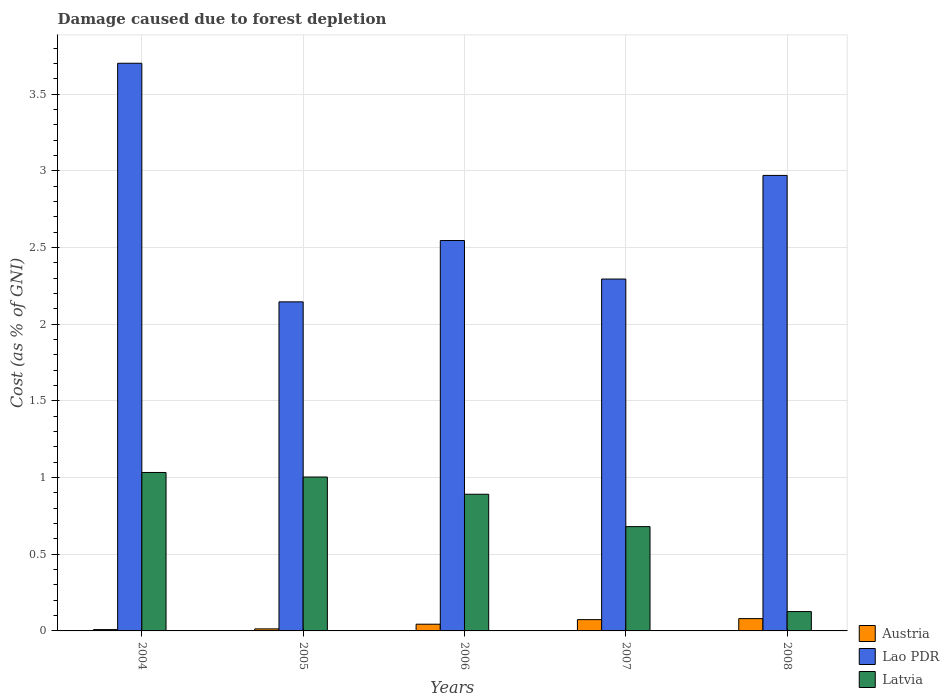Are the number of bars per tick equal to the number of legend labels?
Your answer should be very brief. Yes. How many bars are there on the 2nd tick from the left?
Provide a succinct answer. 3. In how many cases, is the number of bars for a given year not equal to the number of legend labels?
Your response must be concise. 0. What is the cost of damage caused due to forest depletion in Lao PDR in 2005?
Provide a succinct answer. 2.15. Across all years, what is the maximum cost of damage caused due to forest depletion in Lao PDR?
Make the answer very short. 3.7. Across all years, what is the minimum cost of damage caused due to forest depletion in Austria?
Make the answer very short. 0.01. In which year was the cost of damage caused due to forest depletion in Lao PDR maximum?
Offer a very short reply. 2004. In which year was the cost of damage caused due to forest depletion in Austria minimum?
Provide a succinct answer. 2004. What is the total cost of damage caused due to forest depletion in Austria in the graph?
Your response must be concise. 0.22. What is the difference between the cost of damage caused due to forest depletion in Lao PDR in 2005 and that in 2006?
Offer a very short reply. -0.4. What is the difference between the cost of damage caused due to forest depletion in Latvia in 2005 and the cost of damage caused due to forest depletion in Austria in 2004?
Ensure brevity in your answer.  1. What is the average cost of damage caused due to forest depletion in Lao PDR per year?
Provide a succinct answer. 2.73. In the year 2005, what is the difference between the cost of damage caused due to forest depletion in Lao PDR and cost of damage caused due to forest depletion in Latvia?
Your answer should be very brief. 1.14. In how many years, is the cost of damage caused due to forest depletion in Lao PDR greater than 3.7 %?
Provide a succinct answer. 1. What is the ratio of the cost of damage caused due to forest depletion in Lao PDR in 2004 to that in 2008?
Offer a very short reply. 1.25. What is the difference between the highest and the second highest cost of damage caused due to forest depletion in Austria?
Ensure brevity in your answer.  0.01. What is the difference between the highest and the lowest cost of damage caused due to forest depletion in Austria?
Your answer should be very brief. 0.07. In how many years, is the cost of damage caused due to forest depletion in Lao PDR greater than the average cost of damage caused due to forest depletion in Lao PDR taken over all years?
Provide a succinct answer. 2. Is the sum of the cost of damage caused due to forest depletion in Austria in 2005 and 2007 greater than the maximum cost of damage caused due to forest depletion in Latvia across all years?
Provide a short and direct response. No. What does the 3rd bar from the left in 2004 represents?
Ensure brevity in your answer.  Latvia. What does the 3rd bar from the right in 2006 represents?
Make the answer very short. Austria. How many bars are there?
Give a very brief answer. 15. Are all the bars in the graph horizontal?
Offer a very short reply. No. Are the values on the major ticks of Y-axis written in scientific E-notation?
Keep it short and to the point. No. Does the graph contain any zero values?
Ensure brevity in your answer.  No. How many legend labels are there?
Ensure brevity in your answer.  3. How are the legend labels stacked?
Offer a terse response. Vertical. What is the title of the graph?
Keep it short and to the point. Damage caused due to forest depletion. Does "Korea (Democratic)" appear as one of the legend labels in the graph?
Provide a succinct answer. No. What is the label or title of the X-axis?
Offer a terse response. Years. What is the label or title of the Y-axis?
Provide a succinct answer. Cost (as % of GNI). What is the Cost (as % of GNI) of Austria in 2004?
Give a very brief answer. 0.01. What is the Cost (as % of GNI) of Lao PDR in 2004?
Offer a terse response. 3.7. What is the Cost (as % of GNI) in Latvia in 2004?
Ensure brevity in your answer.  1.03. What is the Cost (as % of GNI) of Austria in 2005?
Ensure brevity in your answer.  0.01. What is the Cost (as % of GNI) of Lao PDR in 2005?
Provide a succinct answer. 2.15. What is the Cost (as % of GNI) of Latvia in 2005?
Offer a terse response. 1. What is the Cost (as % of GNI) in Austria in 2006?
Give a very brief answer. 0.04. What is the Cost (as % of GNI) in Lao PDR in 2006?
Make the answer very short. 2.55. What is the Cost (as % of GNI) of Latvia in 2006?
Give a very brief answer. 0.89. What is the Cost (as % of GNI) of Austria in 2007?
Offer a terse response. 0.07. What is the Cost (as % of GNI) in Lao PDR in 2007?
Provide a succinct answer. 2.29. What is the Cost (as % of GNI) of Latvia in 2007?
Provide a short and direct response. 0.68. What is the Cost (as % of GNI) of Austria in 2008?
Make the answer very short. 0.08. What is the Cost (as % of GNI) in Lao PDR in 2008?
Provide a short and direct response. 2.97. What is the Cost (as % of GNI) of Latvia in 2008?
Provide a succinct answer. 0.13. Across all years, what is the maximum Cost (as % of GNI) of Austria?
Your answer should be very brief. 0.08. Across all years, what is the maximum Cost (as % of GNI) of Lao PDR?
Offer a very short reply. 3.7. Across all years, what is the maximum Cost (as % of GNI) in Latvia?
Your response must be concise. 1.03. Across all years, what is the minimum Cost (as % of GNI) in Austria?
Keep it short and to the point. 0.01. Across all years, what is the minimum Cost (as % of GNI) in Lao PDR?
Make the answer very short. 2.15. Across all years, what is the minimum Cost (as % of GNI) of Latvia?
Offer a terse response. 0.13. What is the total Cost (as % of GNI) in Austria in the graph?
Make the answer very short. 0.22. What is the total Cost (as % of GNI) in Lao PDR in the graph?
Your answer should be very brief. 13.66. What is the total Cost (as % of GNI) of Latvia in the graph?
Provide a succinct answer. 3.73. What is the difference between the Cost (as % of GNI) in Austria in 2004 and that in 2005?
Provide a short and direct response. -0. What is the difference between the Cost (as % of GNI) in Lao PDR in 2004 and that in 2005?
Your answer should be very brief. 1.56. What is the difference between the Cost (as % of GNI) of Latvia in 2004 and that in 2005?
Ensure brevity in your answer.  0.03. What is the difference between the Cost (as % of GNI) in Austria in 2004 and that in 2006?
Your answer should be compact. -0.04. What is the difference between the Cost (as % of GNI) in Lao PDR in 2004 and that in 2006?
Keep it short and to the point. 1.16. What is the difference between the Cost (as % of GNI) in Latvia in 2004 and that in 2006?
Your answer should be compact. 0.14. What is the difference between the Cost (as % of GNI) in Austria in 2004 and that in 2007?
Offer a terse response. -0.06. What is the difference between the Cost (as % of GNI) in Lao PDR in 2004 and that in 2007?
Offer a terse response. 1.41. What is the difference between the Cost (as % of GNI) in Latvia in 2004 and that in 2007?
Provide a short and direct response. 0.35. What is the difference between the Cost (as % of GNI) of Austria in 2004 and that in 2008?
Your answer should be very brief. -0.07. What is the difference between the Cost (as % of GNI) in Lao PDR in 2004 and that in 2008?
Keep it short and to the point. 0.73. What is the difference between the Cost (as % of GNI) of Latvia in 2004 and that in 2008?
Make the answer very short. 0.91. What is the difference between the Cost (as % of GNI) in Austria in 2005 and that in 2006?
Your answer should be very brief. -0.03. What is the difference between the Cost (as % of GNI) of Lao PDR in 2005 and that in 2006?
Your answer should be very brief. -0.4. What is the difference between the Cost (as % of GNI) in Latvia in 2005 and that in 2006?
Offer a very short reply. 0.11. What is the difference between the Cost (as % of GNI) in Austria in 2005 and that in 2007?
Ensure brevity in your answer.  -0.06. What is the difference between the Cost (as % of GNI) of Lao PDR in 2005 and that in 2007?
Provide a succinct answer. -0.15. What is the difference between the Cost (as % of GNI) of Latvia in 2005 and that in 2007?
Give a very brief answer. 0.32. What is the difference between the Cost (as % of GNI) in Austria in 2005 and that in 2008?
Give a very brief answer. -0.07. What is the difference between the Cost (as % of GNI) in Lao PDR in 2005 and that in 2008?
Your answer should be compact. -0.82. What is the difference between the Cost (as % of GNI) in Latvia in 2005 and that in 2008?
Offer a very short reply. 0.88. What is the difference between the Cost (as % of GNI) in Austria in 2006 and that in 2007?
Your response must be concise. -0.03. What is the difference between the Cost (as % of GNI) of Lao PDR in 2006 and that in 2007?
Your response must be concise. 0.25. What is the difference between the Cost (as % of GNI) in Latvia in 2006 and that in 2007?
Provide a short and direct response. 0.21. What is the difference between the Cost (as % of GNI) in Austria in 2006 and that in 2008?
Provide a succinct answer. -0.04. What is the difference between the Cost (as % of GNI) in Lao PDR in 2006 and that in 2008?
Provide a succinct answer. -0.42. What is the difference between the Cost (as % of GNI) in Latvia in 2006 and that in 2008?
Ensure brevity in your answer.  0.77. What is the difference between the Cost (as % of GNI) of Austria in 2007 and that in 2008?
Keep it short and to the point. -0.01. What is the difference between the Cost (as % of GNI) of Lao PDR in 2007 and that in 2008?
Your answer should be compact. -0.68. What is the difference between the Cost (as % of GNI) in Latvia in 2007 and that in 2008?
Provide a succinct answer. 0.55. What is the difference between the Cost (as % of GNI) of Austria in 2004 and the Cost (as % of GNI) of Lao PDR in 2005?
Give a very brief answer. -2.14. What is the difference between the Cost (as % of GNI) in Austria in 2004 and the Cost (as % of GNI) in Latvia in 2005?
Provide a succinct answer. -0.99. What is the difference between the Cost (as % of GNI) of Lao PDR in 2004 and the Cost (as % of GNI) of Latvia in 2005?
Keep it short and to the point. 2.7. What is the difference between the Cost (as % of GNI) in Austria in 2004 and the Cost (as % of GNI) in Lao PDR in 2006?
Make the answer very short. -2.54. What is the difference between the Cost (as % of GNI) in Austria in 2004 and the Cost (as % of GNI) in Latvia in 2006?
Offer a very short reply. -0.88. What is the difference between the Cost (as % of GNI) of Lao PDR in 2004 and the Cost (as % of GNI) of Latvia in 2006?
Make the answer very short. 2.81. What is the difference between the Cost (as % of GNI) in Austria in 2004 and the Cost (as % of GNI) in Lao PDR in 2007?
Give a very brief answer. -2.29. What is the difference between the Cost (as % of GNI) in Austria in 2004 and the Cost (as % of GNI) in Latvia in 2007?
Your answer should be very brief. -0.67. What is the difference between the Cost (as % of GNI) in Lao PDR in 2004 and the Cost (as % of GNI) in Latvia in 2007?
Provide a succinct answer. 3.02. What is the difference between the Cost (as % of GNI) of Austria in 2004 and the Cost (as % of GNI) of Lao PDR in 2008?
Your response must be concise. -2.96. What is the difference between the Cost (as % of GNI) of Austria in 2004 and the Cost (as % of GNI) of Latvia in 2008?
Your response must be concise. -0.12. What is the difference between the Cost (as % of GNI) in Lao PDR in 2004 and the Cost (as % of GNI) in Latvia in 2008?
Provide a succinct answer. 3.58. What is the difference between the Cost (as % of GNI) in Austria in 2005 and the Cost (as % of GNI) in Lao PDR in 2006?
Give a very brief answer. -2.53. What is the difference between the Cost (as % of GNI) in Austria in 2005 and the Cost (as % of GNI) in Latvia in 2006?
Your answer should be compact. -0.88. What is the difference between the Cost (as % of GNI) in Lao PDR in 2005 and the Cost (as % of GNI) in Latvia in 2006?
Provide a succinct answer. 1.25. What is the difference between the Cost (as % of GNI) in Austria in 2005 and the Cost (as % of GNI) in Lao PDR in 2007?
Give a very brief answer. -2.28. What is the difference between the Cost (as % of GNI) of Austria in 2005 and the Cost (as % of GNI) of Latvia in 2007?
Provide a succinct answer. -0.67. What is the difference between the Cost (as % of GNI) in Lao PDR in 2005 and the Cost (as % of GNI) in Latvia in 2007?
Give a very brief answer. 1.47. What is the difference between the Cost (as % of GNI) of Austria in 2005 and the Cost (as % of GNI) of Lao PDR in 2008?
Make the answer very short. -2.96. What is the difference between the Cost (as % of GNI) of Austria in 2005 and the Cost (as % of GNI) of Latvia in 2008?
Offer a terse response. -0.11. What is the difference between the Cost (as % of GNI) in Lao PDR in 2005 and the Cost (as % of GNI) in Latvia in 2008?
Offer a very short reply. 2.02. What is the difference between the Cost (as % of GNI) of Austria in 2006 and the Cost (as % of GNI) of Lao PDR in 2007?
Provide a succinct answer. -2.25. What is the difference between the Cost (as % of GNI) in Austria in 2006 and the Cost (as % of GNI) in Latvia in 2007?
Provide a short and direct response. -0.64. What is the difference between the Cost (as % of GNI) in Lao PDR in 2006 and the Cost (as % of GNI) in Latvia in 2007?
Keep it short and to the point. 1.87. What is the difference between the Cost (as % of GNI) of Austria in 2006 and the Cost (as % of GNI) of Lao PDR in 2008?
Offer a terse response. -2.93. What is the difference between the Cost (as % of GNI) in Austria in 2006 and the Cost (as % of GNI) in Latvia in 2008?
Offer a very short reply. -0.08. What is the difference between the Cost (as % of GNI) in Lao PDR in 2006 and the Cost (as % of GNI) in Latvia in 2008?
Make the answer very short. 2.42. What is the difference between the Cost (as % of GNI) of Austria in 2007 and the Cost (as % of GNI) of Lao PDR in 2008?
Offer a terse response. -2.9. What is the difference between the Cost (as % of GNI) of Austria in 2007 and the Cost (as % of GNI) of Latvia in 2008?
Make the answer very short. -0.05. What is the difference between the Cost (as % of GNI) in Lao PDR in 2007 and the Cost (as % of GNI) in Latvia in 2008?
Make the answer very short. 2.17. What is the average Cost (as % of GNI) of Austria per year?
Your answer should be compact. 0.04. What is the average Cost (as % of GNI) of Lao PDR per year?
Your response must be concise. 2.73. What is the average Cost (as % of GNI) of Latvia per year?
Give a very brief answer. 0.75. In the year 2004, what is the difference between the Cost (as % of GNI) in Austria and Cost (as % of GNI) in Lao PDR?
Make the answer very short. -3.69. In the year 2004, what is the difference between the Cost (as % of GNI) of Austria and Cost (as % of GNI) of Latvia?
Offer a very short reply. -1.02. In the year 2004, what is the difference between the Cost (as % of GNI) in Lao PDR and Cost (as % of GNI) in Latvia?
Your answer should be very brief. 2.67. In the year 2005, what is the difference between the Cost (as % of GNI) in Austria and Cost (as % of GNI) in Lao PDR?
Your answer should be compact. -2.13. In the year 2005, what is the difference between the Cost (as % of GNI) of Austria and Cost (as % of GNI) of Latvia?
Ensure brevity in your answer.  -0.99. In the year 2005, what is the difference between the Cost (as % of GNI) in Lao PDR and Cost (as % of GNI) in Latvia?
Make the answer very short. 1.14. In the year 2006, what is the difference between the Cost (as % of GNI) in Austria and Cost (as % of GNI) in Lao PDR?
Provide a succinct answer. -2.5. In the year 2006, what is the difference between the Cost (as % of GNI) in Austria and Cost (as % of GNI) in Latvia?
Ensure brevity in your answer.  -0.85. In the year 2006, what is the difference between the Cost (as % of GNI) of Lao PDR and Cost (as % of GNI) of Latvia?
Provide a short and direct response. 1.65. In the year 2007, what is the difference between the Cost (as % of GNI) of Austria and Cost (as % of GNI) of Lao PDR?
Your answer should be compact. -2.22. In the year 2007, what is the difference between the Cost (as % of GNI) of Austria and Cost (as % of GNI) of Latvia?
Keep it short and to the point. -0.61. In the year 2007, what is the difference between the Cost (as % of GNI) of Lao PDR and Cost (as % of GNI) of Latvia?
Your response must be concise. 1.61. In the year 2008, what is the difference between the Cost (as % of GNI) in Austria and Cost (as % of GNI) in Lao PDR?
Keep it short and to the point. -2.89. In the year 2008, what is the difference between the Cost (as % of GNI) in Austria and Cost (as % of GNI) in Latvia?
Offer a very short reply. -0.05. In the year 2008, what is the difference between the Cost (as % of GNI) of Lao PDR and Cost (as % of GNI) of Latvia?
Ensure brevity in your answer.  2.84. What is the ratio of the Cost (as % of GNI) of Austria in 2004 to that in 2005?
Your answer should be very brief. 0.65. What is the ratio of the Cost (as % of GNI) in Lao PDR in 2004 to that in 2005?
Provide a succinct answer. 1.73. What is the ratio of the Cost (as % of GNI) in Latvia in 2004 to that in 2005?
Keep it short and to the point. 1.03. What is the ratio of the Cost (as % of GNI) in Austria in 2004 to that in 2006?
Keep it short and to the point. 0.2. What is the ratio of the Cost (as % of GNI) of Lao PDR in 2004 to that in 2006?
Your answer should be very brief. 1.45. What is the ratio of the Cost (as % of GNI) in Latvia in 2004 to that in 2006?
Offer a terse response. 1.16. What is the ratio of the Cost (as % of GNI) in Austria in 2004 to that in 2007?
Provide a short and direct response. 0.12. What is the ratio of the Cost (as % of GNI) in Lao PDR in 2004 to that in 2007?
Ensure brevity in your answer.  1.61. What is the ratio of the Cost (as % of GNI) in Latvia in 2004 to that in 2007?
Ensure brevity in your answer.  1.52. What is the ratio of the Cost (as % of GNI) in Austria in 2004 to that in 2008?
Offer a very short reply. 0.11. What is the ratio of the Cost (as % of GNI) in Lao PDR in 2004 to that in 2008?
Your answer should be very brief. 1.25. What is the ratio of the Cost (as % of GNI) in Latvia in 2004 to that in 2008?
Offer a very short reply. 8.19. What is the ratio of the Cost (as % of GNI) in Austria in 2005 to that in 2006?
Your answer should be very brief. 0.3. What is the ratio of the Cost (as % of GNI) in Lao PDR in 2005 to that in 2006?
Your answer should be very brief. 0.84. What is the ratio of the Cost (as % of GNI) of Latvia in 2005 to that in 2006?
Provide a succinct answer. 1.13. What is the ratio of the Cost (as % of GNI) of Austria in 2005 to that in 2007?
Offer a terse response. 0.18. What is the ratio of the Cost (as % of GNI) in Lao PDR in 2005 to that in 2007?
Your answer should be very brief. 0.94. What is the ratio of the Cost (as % of GNI) of Latvia in 2005 to that in 2007?
Your response must be concise. 1.48. What is the ratio of the Cost (as % of GNI) in Austria in 2005 to that in 2008?
Give a very brief answer. 0.17. What is the ratio of the Cost (as % of GNI) in Lao PDR in 2005 to that in 2008?
Ensure brevity in your answer.  0.72. What is the ratio of the Cost (as % of GNI) in Latvia in 2005 to that in 2008?
Make the answer very short. 7.95. What is the ratio of the Cost (as % of GNI) in Austria in 2006 to that in 2007?
Your answer should be compact. 0.59. What is the ratio of the Cost (as % of GNI) of Lao PDR in 2006 to that in 2007?
Give a very brief answer. 1.11. What is the ratio of the Cost (as % of GNI) in Latvia in 2006 to that in 2007?
Ensure brevity in your answer.  1.31. What is the ratio of the Cost (as % of GNI) of Austria in 2006 to that in 2008?
Give a very brief answer. 0.55. What is the ratio of the Cost (as % of GNI) of Lao PDR in 2006 to that in 2008?
Provide a short and direct response. 0.86. What is the ratio of the Cost (as % of GNI) in Latvia in 2006 to that in 2008?
Your answer should be compact. 7.06. What is the ratio of the Cost (as % of GNI) in Austria in 2007 to that in 2008?
Ensure brevity in your answer.  0.92. What is the ratio of the Cost (as % of GNI) of Lao PDR in 2007 to that in 2008?
Your response must be concise. 0.77. What is the ratio of the Cost (as % of GNI) of Latvia in 2007 to that in 2008?
Keep it short and to the point. 5.39. What is the difference between the highest and the second highest Cost (as % of GNI) of Austria?
Your answer should be compact. 0.01. What is the difference between the highest and the second highest Cost (as % of GNI) in Lao PDR?
Provide a short and direct response. 0.73. What is the difference between the highest and the second highest Cost (as % of GNI) in Latvia?
Your response must be concise. 0.03. What is the difference between the highest and the lowest Cost (as % of GNI) of Austria?
Provide a short and direct response. 0.07. What is the difference between the highest and the lowest Cost (as % of GNI) of Lao PDR?
Provide a short and direct response. 1.56. What is the difference between the highest and the lowest Cost (as % of GNI) in Latvia?
Offer a very short reply. 0.91. 